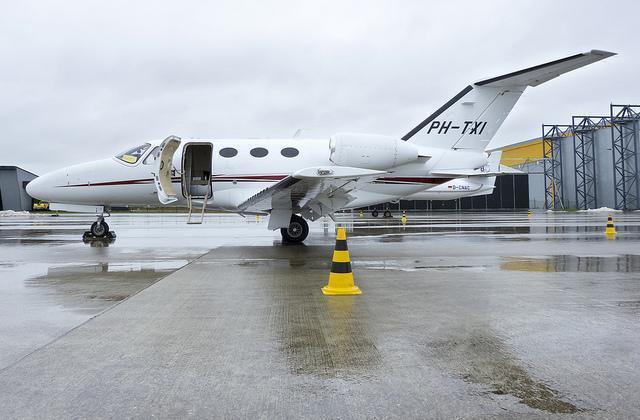How many people have blue uniforms?
Give a very brief answer. 0. 